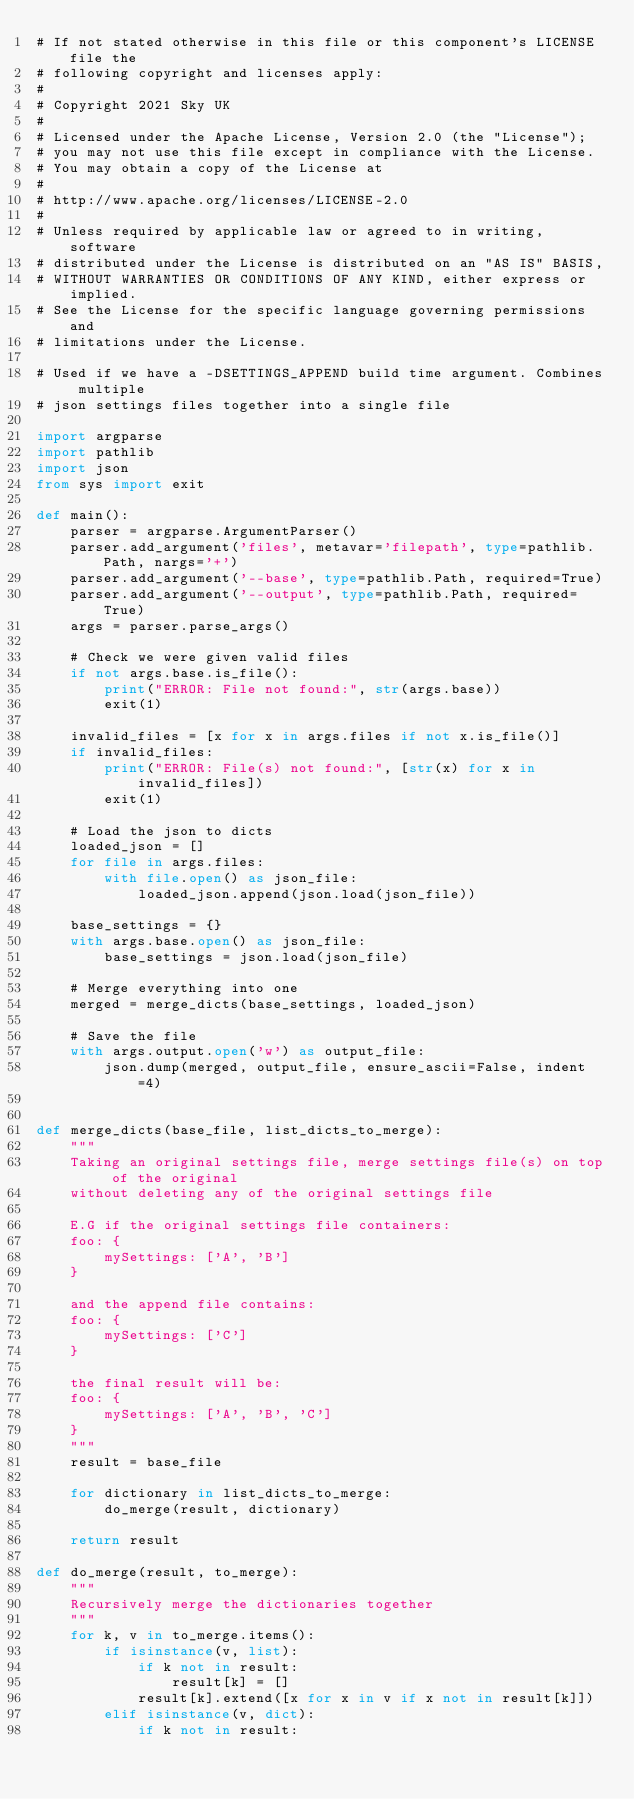Convert code to text. <code><loc_0><loc_0><loc_500><loc_500><_Python_># If not stated otherwise in this file or this component's LICENSE file the
# following copyright and licenses apply:
#
# Copyright 2021 Sky UK
#
# Licensed under the Apache License, Version 2.0 (the "License");
# you may not use this file except in compliance with the License.
# You may obtain a copy of the License at
#
# http://www.apache.org/licenses/LICENSE-2.0
#
# Unless required by applicable law or agreed to in writing, software
# distributed under the License is distributed on an "AS IS" BASIS,
# WITHOUT WARRANTIES OR CONDITIONS OF ANY KIND, either express or implied.
# See the License for the specific language governing permissions and
# limitations under the License.

# Used if we have a -DSETTINGS_APPEND build time argument. Combines multiple
# json settings files together into a single file

import argparse
import pathlib
import json
from sys import exit

def main():
    parser = argparse.ArgumentParser()
    parser.add_argument('files', metavar='filepath', type=pathlib.Path, nargs='+')
    parser.add_argument('--base', type=pathlib.Path, required=True)
    parser.add_argument('--output', type=pathlib.Path, required=True)
    args = parser.parse_args()

    # Check we were given valid files
    if not args.base.is_file():
        print("ERROR: File not found:", str(args.base))
        exit(1)

    invalid_files = [x for x in args.files if not x.is_file()]
    if invalid_files:
        print("ERROR: File(s) not found:", [str(x) for x in invalid_files])
        exit(1)

    # Load the json to dicts
    loaded_json = []
    for file in args.files:
        with file.open() as json_file:
            loaded_json.append(json.load(json_file))

    base_settings = {}
    with args.base.open() as json_file:
        base_settings = json.load(json_file)

    # Merge everything into one
    merged = merge_dicts(base_settings, loaded_json)

    # Save the file
    with args.output.open('w') as output_file:
        json.dump(merged, output_file, ensure_ascii=False, indent=4)


def merge_dicts(base_file, list_dicts_to_merge):
    """
    Taking an original settings file, merge settings file(s) on top of the original
    without deleting any of the original settings file

    E.G if the original settings file containers:
    foo: {
        mySettings: ['A', 'B']
    }

    and the append file contains:
    foo: {
        mySettings: ['C']
    }

    the final result will be:
    foo: {
        mySettings: ['A', 'B', 'C']
    }
    """
    result = base_file

    for dictionary in list_dicts_to_merge:
        do_merge(result, dictionary)

    return result

def do_merge(result, to_merge):
    """
    Recursively merge the dictionaries together
    """
    for k, v in to_merge.items():
        if isinstance(v, list):
            if k not in result:
                result[k] = []
            result[k].extend([x for x in v if x not in result[k]])
        elif isinstance(v, dict):
            if k not in result:</code> 